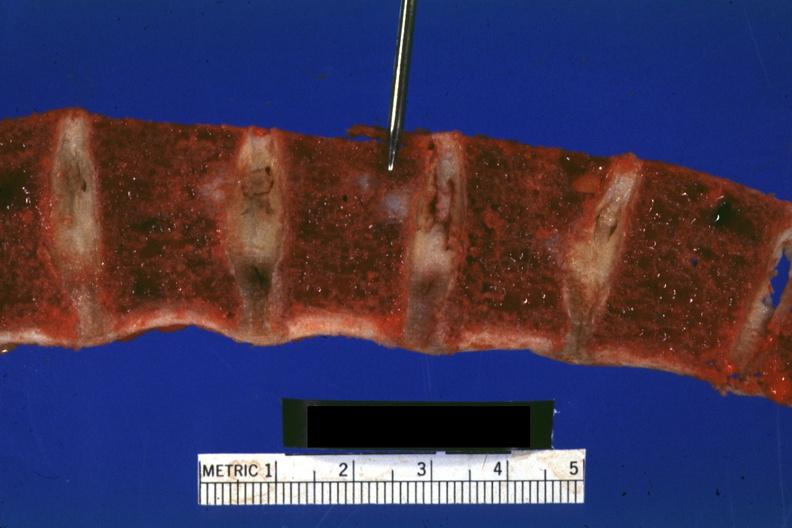does this image show vertebral bodies with typical gelatinous-hemorrhagic lesions?
Answer the question using a single word or phrase. Yes 